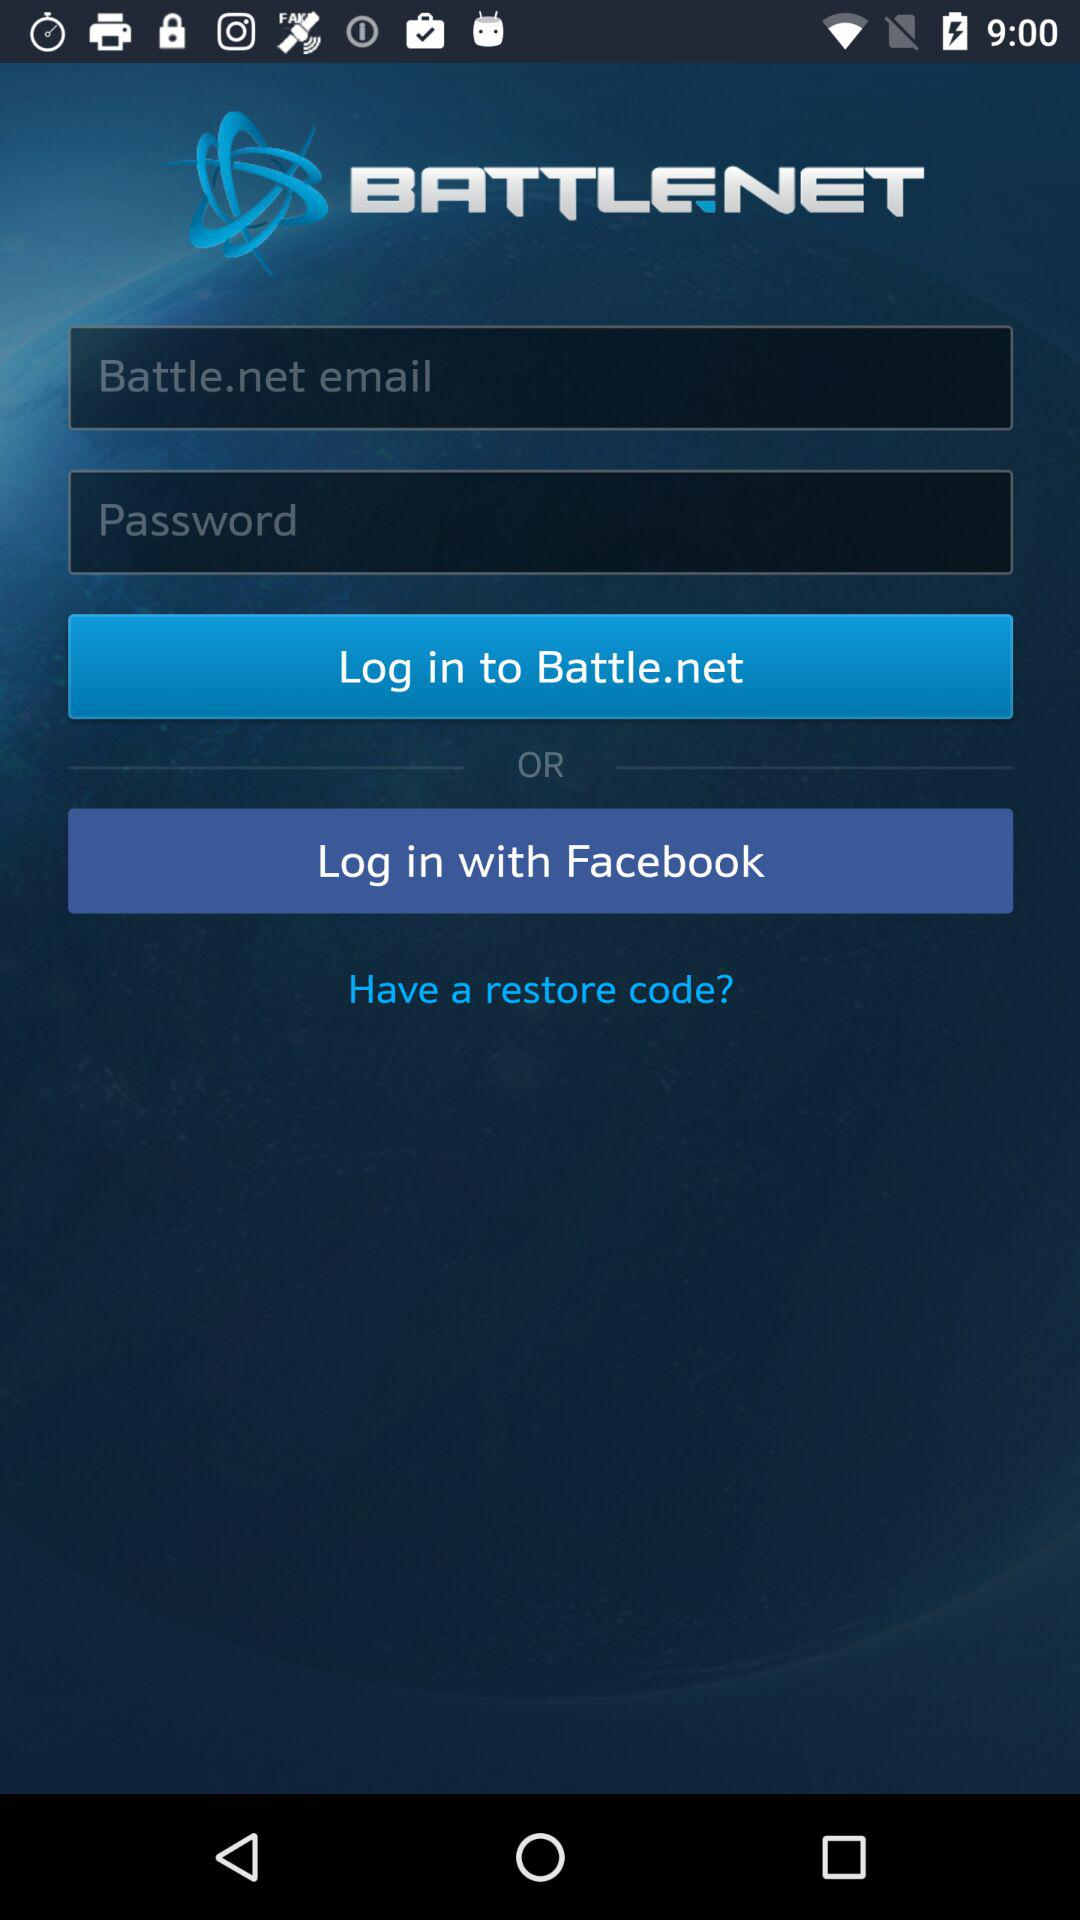Through what application can we log in? You can log in through "Facebook". 